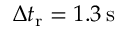<formula> <loc_0><loc_0><loc_500><loc_500>\Delta t _ { r } = 1 . 3 \, s</formula> 